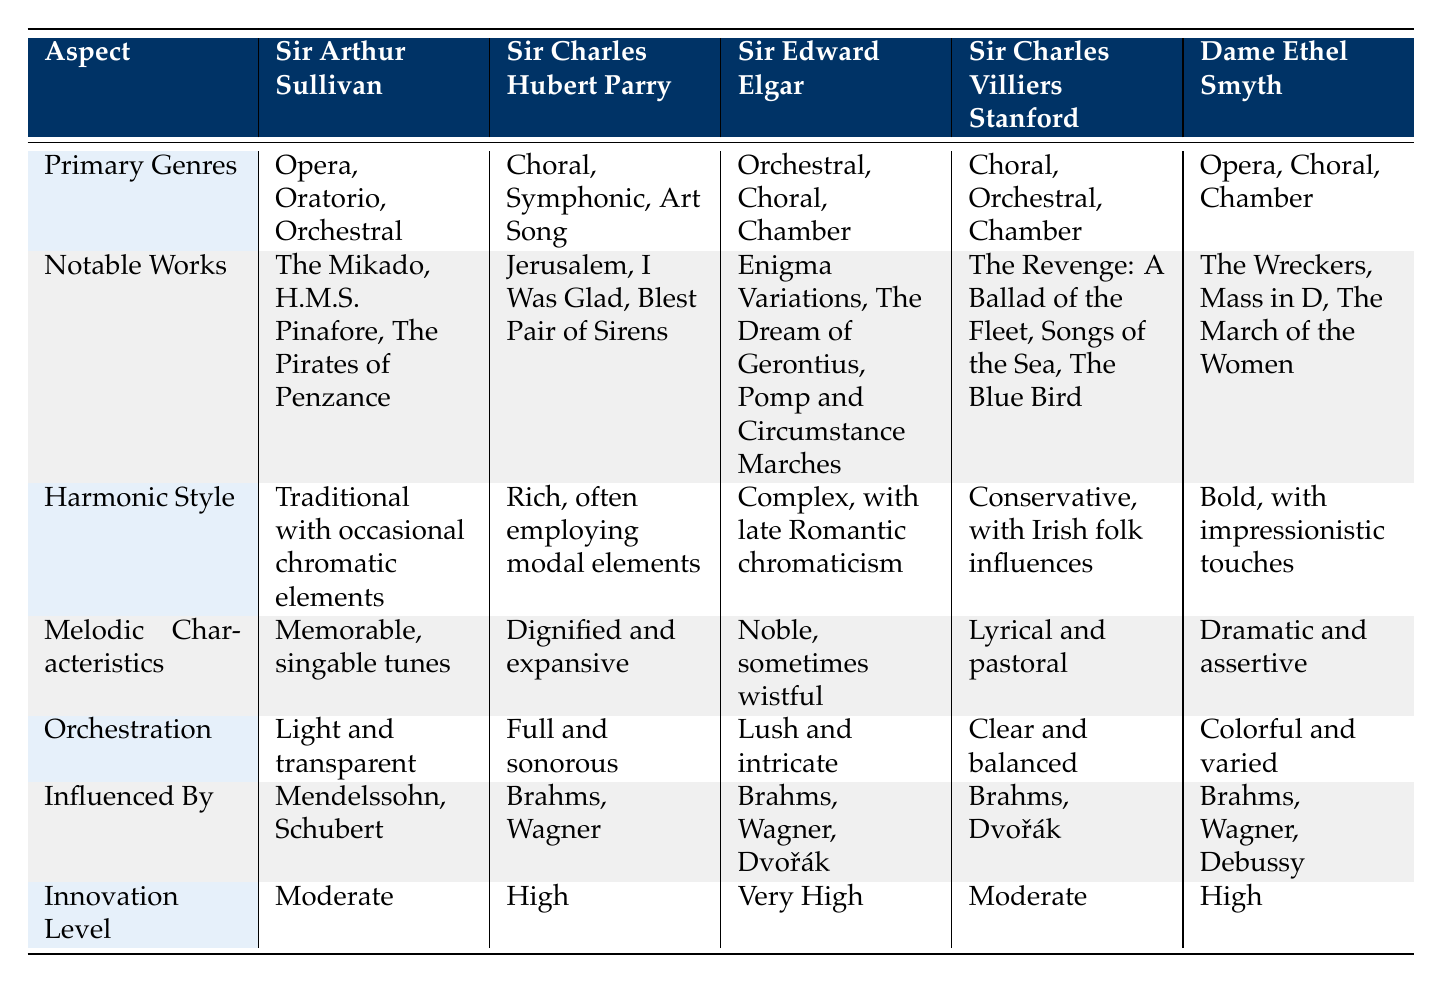What are the primary genres of Sir Edward Elgar? According to the table, Sir Edward Elgar's primary genres are Orchestral, Choral, and Chamber.
Answer: Orchestral, Choral, Chamber Which composer has the most complex harmonic style? The table states that Sir Edward Elgar has a harmonic style described as "Complex, with late Romantic chromaticism," which indicates a higher level of complexity compared to the others.
Answer: Sir Edward Elgar True or False: Dame Ethel Smyth is influenced by Debussy. The table lists "Brahms, Wagner, Debussy" as influences on Dame Ethel Smyth, confirming the statement is true.
Answer: True What are the notable works of Sir Charles Villiers Stanford? The noted works of Sir Charles Villiers Stanford are "The Revenge: A Ballad of the Fleet," "Songs of the Sea," and "The Blue Bird," as per the table.
Answer: The Revenge: A Ballad of the Fleet, Songs of the Sea, The Blue Bird Which composers have a high level of innovation? The table shows that both Sir Charles Hubert Parry and Dame Ethel Smyth have an innovation level marked as "High."
Answer: Sir Charles Hubert Parry, Dame Ethel Smyth If the harmonic styles were ranked from most complex to least complex, who would be ranked first? Sir Edward Elgar has the most complex harmonic style listed as "Complex, with late Romantic chromaticism," while others have styles that are either traditional, rich, conservative, or bold, indicating that Elgar would be ranked first.
Answer: Sir Edward Elgar How many composers primarily focus on orchestral music according to the table? Sir Arthur Sullivan, Sir Edward Elgar, and Sir Charles Villiers Stanford are the composers listed with orchestral as one of their primary genres, resulting in a total of three composers.
Answer: Three composers Are there any composers who have an innovation level marked as Moderate? The table states that both Sir Arthur Sullivan and Sir Charles Villiers Stanford have an innovation level of "Moderate," confirming the existence of composers with this level.
Answer: Yes What is the melodic characteristic that distinguishes Dame Ethel Smyth from Sir Arthur Sullivan? The table indicates that Dame Ethel Smyth's melodic characteristics are described as "Dramatic and assertive," while Sir Arthur Sullivan's are "Memorable, singable tunes," highlighting the assertive nature of Smyth's melodies as distinctive.
Answer: Dramatic and assertive 